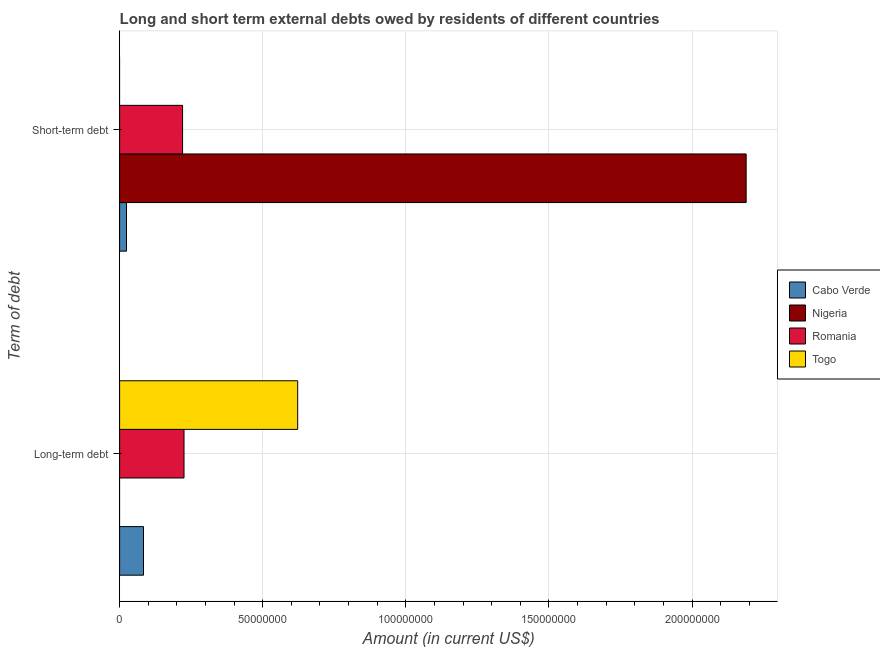How many groups of bars are there?
Your answer should be very brief. 2. What is the label of the 2nd group of bars from the top?
Give a very brief answer. Long-term debt. What is the long-term debts owed by residents in Togo?
Provide a succinct answer. 6.22e+07. Across all countries, what is the maximum long-term debts owed by residents?
Provide a short and direct response. 6.22e+07. In which country was the short-term debts owed by residents maximum?
Keep it short and to the point. Nigeria. What is the total short-term debts owed by residents in the graph?
Offer a terse response. 2.43e+08. What is the difference between the long-term debts owed by residents in Cabo Verde and that in Togo?
Ensure brevity in your answer.  -5.39e+07. What is the difference between the long-term debts owed by residents in Romania and the short-term debts owed by residents in Togo?
Keep it short and to the point. 2.25e+07. What is the average long-term debts owed by residents per country?
Provide a succinct answer. 2.33e+07. What is the difference between the long-term debts owed by residents and short-term debts owed by residents in Cabo Verde?
Provide a succinct answer. 5.95e+06. In how many countries, is the long-term debts owed by residents greater than 80000000 US$?
Offer a very short reply. 0. What is the ratio of the short-term debts owed by residents in Romania to that in Cabo Verde?
Make the answer very short. 9.17. Is the short-term debts owed by residents in Cabo Verde less than that in Romania?
Provide a succinct answer. Yes. How many countries are there in the graph?
Your response must be concise. 4. What is the difference between two consecutive major ticks on the X-axis?
Offer a terse response. 5.00e+07. Does the graph contain any zero values?
Provide a succinct answer. Yes. Does the graph contain grids?
Your answer should be compact. Yes. How many legend labels are there?
Provide a succinct answer. 4. How are the legend labels stacked?
Provide a succinct answer. Vertical. What is the title of the graph?
Offer a very short reply. Long and short term external debts owed by residents of different countries. What is the label or title of the Y-axis?
Offer a terse response. Term of debt. What is the Amount (in current US$) of Cabo Verde in Long-term debt?
Provide a short and direct response. 8.35e+06. What is the Amount (in current US$) in Nigeria in Long-term debt?
Offer a very short reply. 0. What is the Amount (in current US$) in Romania in Long-term debt?
Your answer should be very brief. 2.25e+07. What is the Amount (in current US$) of Togo in Long-term debt?
Give a very brief answer. 6.22e+07. What is the Amount (in current US$) in Cabo Verde in Short-term debt?
Give a very brief answer. 2.40e+06. What is the Amount (in current US$) in Nigeria in Short-term debt?
Your answer should be compact. 2.19e+08. What is the Amount (in current US$) of Romania in Short-term debt?
Offer a terse response. 2.20e+07. Across all Term of debt, what is the maximum Amount (in current US$) of Cabo Verde?
Provide a succinct answer. 8.35e+06. Across all Term of debt, what is the maximum Amount (in current US$) in Nigeria?
Provide a succinct answer. 2.19e+08. Across all Term of debt, what is the maximum Amount (in current US$) in Romania?
Your answer should be very brief. 2.25e+07. Across all Term of debt, what is the maximum Amount (in current US$) of Togo?
Provide a short and direct response. 6.22e+07. Across all Term of debt, what is the minimum Amount (in current US$) of Cabo Verde?
Ensure brevity in your answer.  2.40e+06. Across all Term of debt, what is the minimum Amount (in current US$) in Romania?
Keep it short and to the point. 2.20e+07. What is the total Amount (in current US$) of Cabo Verde in the graph?
Your answer should be compact. 1.07e+07. What is the total Amount (in current US$) in Nigeria in the graph?
Make the answer very short. 2.19e+08. What is the total Amount (in current US$) of Romania in the graph?
Provide a short and direct response. 4.45e+07. What is the total Amount (in current US$) in Togo in the graph?
Keep it short and to the point. 6.22e+07. What is the difference between the Amount (in current US$) of Cabo Verde in Long-term debt and that in Short-term debt?
Provide a succinct answer. 5.95e+06. What is the difference between the Amount (in current US$) of Romania in Long-term debt and that in Short-term debt?
Offer a terse response. 4.99e+05. What is the difference between the Amount (in current US$) in Cabo Verde in Long-term debt and the Amount (in current US$) in Nigeria in Short-term debt?
Make the answer very short. -2.11e+08. What is the difference between the Amount (in current US$) of Cabo Verde in Long-term debt and the Amount (in current US$) of Romania in Short-term debt?
Provide a succinct answer. -1.37e+07. What is the average Amount (in current US$) in Cabo Verde per Term of debt?
Your answer should be very brief. 5.37e+06. What is the average Amount (in current US$) of Nigeria per Term of debt?
Offer a very short reply. 1.09e+08. What is the average Amount (in current US$) in Romania per Term of debt?
Give a very brief answer. 2.22e+07. What is the average Amount (in current US$) of Togo per Term of debt?
Provide a succinct answer. 3.11e+07. What is the difference between the Amount (in current US$) in Cabo Verde and Amount (in current US$) in Romania in Long-term debt?
Provide a short and direct response. -1.42e+07. What is the difference between the Amount (in current US$) of Cabo Verde and Amount (in current US$) of Togo in Long-term debt?
Provide a short and direct response. -5.39e+07. What is the difference between the Amount (in current US$) in Romania and Amount (in current US$) in Togo in Long-term debt?
Ensure brevity in your answer.  -3.97e+07. What is the difference between the Amount (in current US$) in Cabo Verde and Amount (in current US$) in Nigeria in Short-term debt?
Offer a terse response. -2.16e+08. What is the difference between the Amount (in current US$) in Cabo Verde and Amount (in current US$) in Romania in Short-term debt?
Keep it short and to the point. -1.96e+07. What is the difference between the Amount (in current US$) in Nigeria and Amount (in current US$) in Romania in Short-term debt?
Give a very brief answer. 1.97e+08. What is the ratio of the Amount (in current US$) in Cabo Verde in Long-term debt to that in Short-term debt?
Offer a very short reply. 3.48. What is the ratio of the Amount (in current US$) in Romania in Long-term debt to that in Short-term debt?
Offer a terse response. 1.02. What is the difference between the highest and the second highest Amount (in current US$) of Cabo Verde?
Your answer should be compact. 5.95e+06. What is the difference between the highest and the second highest Amount (in current US$) of Romania?
Your answer should be very brief. 4.99e+05. What is the difference between the highest and the lowest Amount (in current US$) of Cabo Verde?
Ensure brevity in your answer.  5.95e+06. What is the difference between the highest and the lowest Amount (in current US$) of Nigeria?
Provide a succinct answer. 2.19e+08. What is the difference between the highest and the lowest Amount (in current US$) of Romania?
Your response must be concise. 4.99e+05. What is the difference between the highest and the lowest Amount (in current US$) in Togo?
Ensure brevity in your answer.  6.22e+07. 